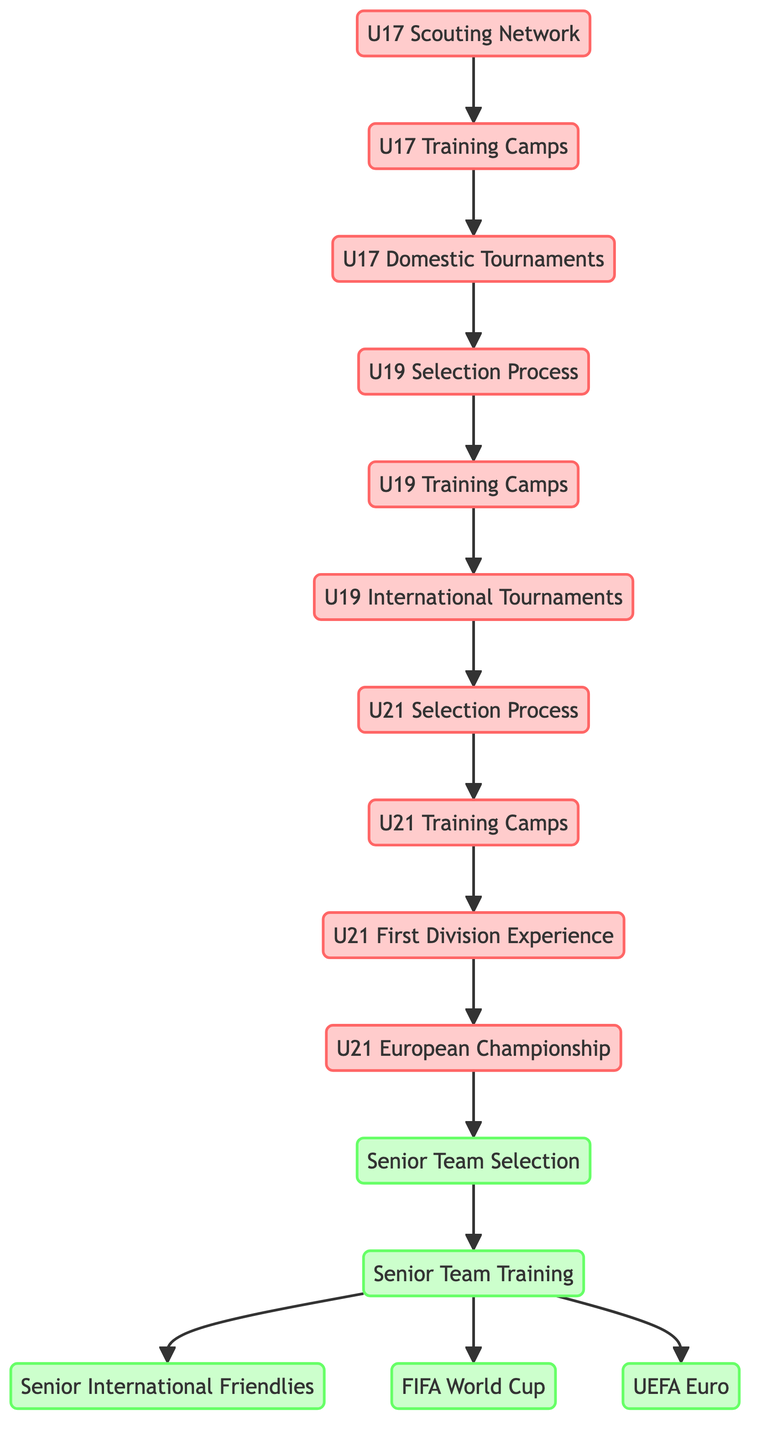What is the starting point of the player development process? The starting point, as indicated in the diagram, is the "U17 Scouting Network," which is the first node connected in the directed graph.
Answer: U17 Scouting Network How many training camps are there in the U19 level? From the diagram, there are two training camps at the U19 level: "U19 Training Camps" and its preceding connection from "U19 Selection Process."
Answer: 1 Which tournament follows the U21 European Championship in the progression to the senior team? The U21 European Championship leads directly to the "Senior Team Selection," indicating that it is a crucial step before reaching the senior level.
Answer: Senior Team Selection What is the last event before participation in UEFA Euro? The last event before participation in UEFA Euro, as seen in the diagram, is "Senior Team Training," which connects to both UEFA Euro and FIFA World Cup options.
Answer: Senior Team Training How many nodes represent international tournaments in the U19 and U21 categories? Two international tournament nodes exist in the diagram: "U19 International Tournaments" for the U19 category and "U21 European Championship" for the U21 category; thus, the total is 2.
Answer: 2 How does "U17 Domestic Tournaments" affect player selection? The "U17 Domestic Tournaments" node connects to "U19 Selection Process," indicating that participation in domestic tournaments directly influences the selection for U19 teams.
Answer: U19 Selection Process What are the final outcomes of "Senior Team Training"? "Senior Team Training" leads to three significant outcomes: "Senior International Friendlies," "FIFA World Cup," and "UEFA Euro," indicating it prepares players for multiple events.
Answer: Senior International Friendlies, FIFA World Cup, UEFA Euro What connects "U21 First Division Experience" to the U21 European Championship? The connection is formed through "U21 Training Camps," which indicates that players gain necessary training experience before participating in the U21 European Championship.
Answer: U21 Training Camps What is the role of "U19 Training Camps" in player progression? "U19 Training Camps" serve as a critical transitional point that prepares players for international tournaments, as evidenced by its connection to "U19 International Tournaments."
Answer: U19 International Tournaments 